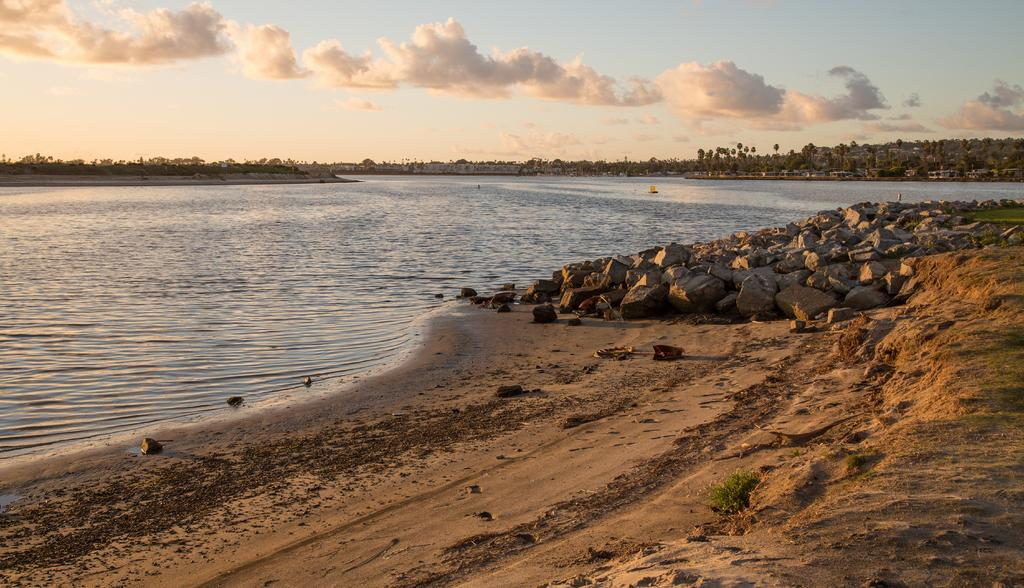What is the main subject of the image? The main subject of the image is water with objects in it. What type of objects can be seen in the water? The provided facts do not specify the objects in the water. What natural elements are visible in the image? Rocks, grass, trees, and the sky are visible in the image. What man-made structures are present in the image? Houses are present in the image. What is the condition of the sky in the image? The sky is visible in the image, and clouds are present. Can you describe the tiger's role in the society depicted in the image? There is no tiger present in the image, nor is there any indication of a society. 